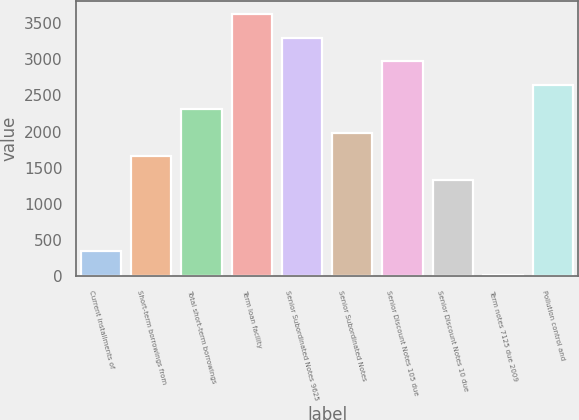Convert chart. <chart><loc_0><loc_0><loc_500><loc_500><bar_chart><fcel>Current installments of<fcel>Short-term borrowings from<fcel>Total short-term borrowings<fcel>Term loan facility<fcel>Senior Subordinated Notes 9625<fcel>Senior Subordinated Notes<fcel>Senior Discount Notes 105 due<fcel>Senior Discount Notes 10 due<fcel>Term notes 7125 due 2009<fcel>Pollution control and<nl><fcel>342.8<fcel>1658<fcel>2315.6<fcel>3630.8<fcel>3302<fcel>1986.8<fcel>2973.2<fcel>1329.2<fcel>14<fcel>2644.4<nl></chart> 